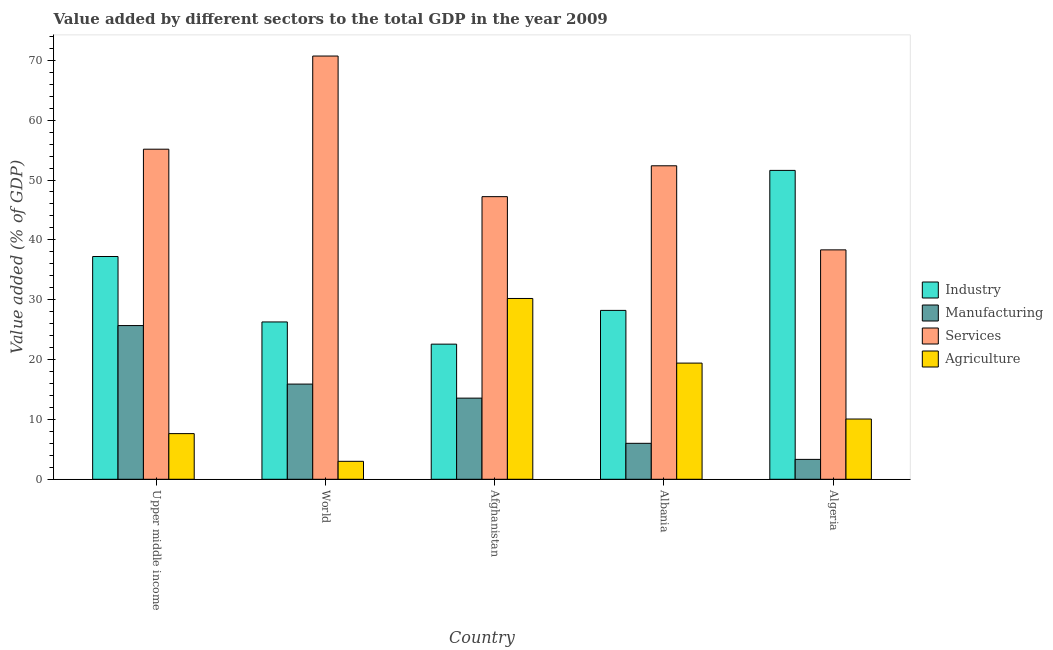What is the label of the 1st group of bars from the left?
Offer a very short reply. Upper middle income. In how many cases, is the number of bars for a given country not equal to the number of legend labels?
Your answer should be compact. 0. What is the value added by agricultural sector in World?
Offer a very short reply. 3. Across all countries, what is the maximum value added by manufacturing sector?
Ensure brevity in your answer.  25.68. Across all countries, what is the minimum value added by agricultural sector?
Provide a short and direct response. 3. In which country was the value added by agricultural sector maximum?
Provide a succinct answer. Afghanistan. What is the total value added by manufacturing sector in the graph?
Provide a succinct answer. 64.47. What is the difference between the value added by services sector in Algeria and that in Upper middle income?
Give a very brief answer. -16.82. What is the difference between the value added by manufacturing sector in Afghanistan and the value added by agricultural sector in Algeria?
Give a very brief answer. 3.49. What is the average value added by services sector per country?
Offer a terse response. 52.76. What is the difference between the value added by manufacturing sector and value added by industrial sector in Upper middle income?
Ensure brevity in your answer.  -11.54. What is the ratio of the value added by agricultural sector in Albania to that in Upper middle income?
Make the answer very short. 2.54. Is the value added by agricultural sector in Afghanistan less than that in Albania?
Make the answer very short. No. Is the difference between the value added by industrial sector in Albania and World greater than the difference between the value added by services sector in Albania and World?
Keep it short and to the point. Yes. What is the difference between the highest and the second highest value added by manufacturing sector?
Provide a succinct answer. 9.78. What is the difference between the highest and the lowest value added by industrial sector?
Ensure brevity in your answer.  29.03. In how many countries, is the value added by industrial sector greater than the average value added by industrial sector taken over all countries?
Provide a short and direct response. 2. Is the sum of the value added by manufacturing sector in Algeria and Upper middle income greater than the maximum value added by agricultural sector across all countries?
Make the answer very short. No. What does the 3rd bar from the left in Afghanistan represents?
Keep it short and to the point. Services. What does the 2nd bar from the right in Upper middle income represents?
Keep it short and to the point. Services. Is it the case that in every country, the sum of the value added by industrial sector and value added by manufacturing sector is greater than the value added by services sector?
Your response must be concise. No. How many bars are there?
Offer a terse response. 20. How many countries are there in the graph?
Give a very brief answer. 5. Does the graph contain grids?
Your answer should be very brief. No. Where does the legend appear in the graph?
Your answer should be very brief. Center right. How many legend labels are there?
Ensure brevity in your answer.  4. What is the title of the graph?
Provide a succinct answer. Value added by different sectors to the total GDP in the year 2009. What is the label or title of the Y-axis?
Make the answer very short. Value added (% of GDP). What is the Value added (% of GDP) of Industry in Upper middle income?
Offer a terse response. 37.22. What is the Value added (% of GDP) of Manufacturing in Upper middle income?
Your answer should be compact. 25.68. What is the Value added (% of GDP) of Services in Upper middle income?
Provide a short and direct response. 55.15. What is the Value added (% of GDP) of Agriculture in Upper middle income?
Provide a succinct answer. 7.63. What is the Value added (% of GDP) of Industry in World?
Your response must be concise. 26.29. What is the Value added (% of GDP) in Manufacturing in World?
Give a very brief answer. 15.9. What is the Value added (% of GDP) in Services in World?
Ensure brevity in your answer.  70.71. What is the Value added (% of GDP) of Agriculture in World?
Your answer should be compact. 3. What is the Value added (% of GDP) of Industry in Afghanistan?
Provide a succinct answer. 22.58. What is the Value added (% of GDP) in Manufacturing in Afghanistan?
Keep it short and to the point. 13.56. What is the Value added (% of GDP) of Services in Afghanistan?
Make the answer very short. 47.22. What is the Value added (% of GDP) of Agriculture in Afghanistan?
Make the answer very short. 30.21. What is the Value added (% of GDP) of Industry in Albania?
Offer a very short reply. 28.22. What is the Value added (% of GDP) in Manufacturing in Albania?
Provide a short and direct response. 6.01. What is the Value added (% of GDP) in Services in Albania?
Provide a short and direct response. 52.37. What is the Value added (% of GDP) of Agriculture in Albania?
Offer a very short reply. 19.41. What is the Value added (% of GDP) in Industry in Algeria?
Give a very brief answer. 51.6. What is the Value added (% of GDP) of Manufacturing in Algeria?
Give a very brief answer. 3.32. What is the Value added (% of GDP) in Services in Algeria?
Your answer should be compact. 38.33. What is the Value added (% of GDP) of Agriculture in Algeria?
Offer a terse response. 10.07. Across all countries, what is the maximum Value added (% of GDP) in Industry?
Your answer should be compact. 51.6. Across all countries, what is the maximum Value added (% of GDP) in Manufacturing?
Offer a very short reply. 25.68. Across all countries, what is the maximum Value added (% of GDP) in Services?
Your answer should be very brief. 70.71. Across all countries, what is the maximum Value added (% of GDP) of Agriculture?
Your answer should be very brief. 30.21. Across all countries, what is the minimum Value added (% of GDP) in Industry?
Your answer should be very brief. 22.58. Across all countries, what is the minimum Value added (% of GDP) in Manufacturing?
Your answer should be compact. 3.32. Across all countries, what is the minimum Value added (% of GDP) of Services?
Offer a terse response. 38.33. Across all countries, what is the minimum Value added (% of GDP) of Agriculture?
Provide a short and direct response. 3. What is the total Value added (% of GDP) of Industry in the graph?
Provide a succinct answer. 165.9. What is the total Value added (% of GDP) of Manufacturing in the graph?
Your answer should be compact. 64.47. What is the total Value added (% of GDP) of Services in the graph?
Give a very brief answer. 263.78. What is the total Value added (% of GDP) in Agriculture in the graph?
Your response must be concise. 70.31. What is the difference between the Value added (% of GDP) of Industry in Upper middle income and that in World?
Provide a succinct answer. 10.93. What is the difference between the Value added (% of GDP) of Manufacturing in Upper middle income and that in World?
Keep it short and to the point. 9.78. What is the difference between the Value added (% of GDP) of Services in Upper middle income and that in World?
Your response must be concise. -15.56. What is the difference between the Value added (% of GDP) in Agriculture in Upper middle income and that in World?
Provide a succinct answer. 4.63. What is the difference between the Value added (% of GDP) of Industry in Upper middle income and that in Afghanistan?
Make the answer very short. 14.64. What is the difference between the Value added (% of GDP) of Manufacturing in Upper middle income and that in Afghanistan?
Keep it short and to the point. 12.12. What is the difference between the Value added (% of GDP) in Services in Upper middle income and that in Afghanistan?
Provide a short and direct response. 7.93. What is the difference between the Value added (% of GDP) of Agriculture in Upper middle income and that in Afghanistan?
Offer a very short reply. -22.58. What is the difference between the Value added (% of GDP) of Industry in Upper middle income and that in Albania?
Offer a very short reply. 9. What is the difference between the Value added (% of GDP) in Manufacturing in Upper middle income and that in Albania?
Provide a short and direct response. 19.67. What is the difference between the Value added (% of GDP) of Services in Upper middle income and that in Albania?
Provide a short and direct response. 2.77. What is the difference between the Value added (% of GDP) of Agriculture in Upper middle income and that in Albania?
Your answer should be compact. -11.78. What is the difference between the Value added (% of GDP) in Industry in Upper middle income and that in Algeria?
Make the answer very short. -14.39. What is the difference between the Value added (% of GDP) in Manufacturing in Upper middle income and that in Algeria?
Your response must be concise. 22.36. What is the difference between the Value added (% of GDP) in Services in Upper middle income and that in Algeria?
Keep it short and to the point. 16.82. What is the difference between the Value added (% of GDP) of Agriculture in Upper middle income and that in Algeria?
Offer a terse response. -2.44. What is the difference between the Value added (% of GDP) in Industry in World and that in Afghanistan?
Offer a terse response. 3.71. What is the difference between the Value added (% of GDP) of Manufacturing in World and that in Afghanistan?
Offer a terse response. 2.35. What is the difference between the Value added (% of GDP) in Services in World and that in Afghanistan?
Give a very brief answer. 23.49. What is the difference between the Value added (% of GDP) in Agriculture in World and that in Afghanistan?
Ensure brevity in your answer.  -27.21. What is the difference between the Value added (% of GDP) of Industry in World and that in Albania?
Your response must be concise. -1.93. What is the difference between the Value added (% of GDP) of Manufacturing in World and that in Albania?
Keep it short and to the point. 9.9. What is the difference between the Value added (% of GDP) in Services in World and that in Albania?
Offer a terse response. 18.34. What is the difference between the Value added (% of GDP) of Agriculture in World and that in Albania?
Your answer should be compact. -16.41. What is the difference between the Value added (% of GDP) in Industry in World and that in Algeria?
Offer a very short reply. -25.32. What is the difference between the Value added (% of GDP) in Manufacturing in World and that in Algeria?
Keep it short and to the point. 12.58. What is the difference between the Value added (% of GDP) of Services in World and that in Algeria?
Your response must be concise. 32.38. What is the difference between the Value added (% of GDP) of Agriculture in World and that in Algeria?
Your response must be concise. -7.07. What is the difference between the Value added (% of GDP) of Industry in Afghanistan and that in Albania?
Offer a terse response. -5.64. What is the difference between the Value added (% of GDP) in Manufacturing in Afghanistan and that in Albania?
Keep it short and to the point. 7.55. What is the difference between the Value added (% of GDP) in Services in Afghanistan and that in Albania?
Offer a very short reply. -5.16. What is the difference between the Value added (% of GDP) of Agriculture in Afghanistan and that in Albania?
Provide a short and direct response. 10.8. What is the difference between the Value added (% of GDP) of Industry in Afghanistan and that in Algeria?
Keep it short and to the point. -29.03. What is the difference between the Value added (% of GDP) in Manufacturing in Afghanistan and that in Algeria?
Make the answer very short. 10.23. What is the difference between the Value added (% of GDP) of Services in Afghanistan and that in Algeria?
Keep it short and to the point. 8.89. What is the difference between the Value added (% of GDP) in Agriculture in Afghanistan and that in Algeria?
Provide a succinct answer. 20.14. What is the difference between the Value added (% of GDP) of Industry in Albania and that in Algeria?
Offer a terse response. -23.39. What is the difference between the Value added (% of GDP) in Manufacturing in Albania and that in Algeria?
Offer a terse response. 2.68. What is the difference between the Value added (% of GDP) of Services in Albania and that in Algeria?
Offer a very short reply. 14.05. What is the difference between the Value added (% of GDP) of Agriculture in Albania and that in Algeria?
Offer a very short reply. 9.34. What is the difference between the Value added (% of GDP) of Industry in Upper middle income and the Value added (% of GDP) of Manufacturing in World?
Your answer should be compact. 21.32. What is the difference between the Value added (% of GDP) in Industry in Upper middle income and the Value added (% of GDP) in Services in World?
Provide a short and direct response. -33.49. What is the difference between the Value added (% of GDP) in Industry in Upper middle income and the Value added (% of GDP) in Agriculture in World?
Keep it short and to the point. 34.22. What is the difference between the Value added (% of GDP) in Manufacturing in Upper middle income and the Value added (% of GDP) in Services in World?
Give a very brief answer. -45.03. What is the difference between the Value added (% of GDP) of Manufacturing in Upper middle income and the Value added (% of GDP) of Agriculture in World?
Provide a succinct answer. 22.68. What is the difference between the Value added (% of GDP) of Services in Upper middle income and the Value added (% of GDP) of Agriculture in World?
Ensure brevity in your answer.  52.15. What is the difference between the Value added (% of GDP) of Industry in Upper middle income and the Value added (% of GDP) of Manufacturing in Afghanistan?
Ensure brevity in your answer.  23.66. What is the difference between the Value added (% of GDP) of Industry in Upper middle income and the Value added (% of GDP) of Services in Afghanistan?
Keep it short and to the point. -10. What is the difference between the Value added (% of GDP) of Industry in Upper middle income and the Value added (% of GDP) of Agriculture in Afghanistan?
Keep it short and to the point. 7.01. What is the difference between the Value added (% of GDP) in Manufacturing in Upper middle income and the Value added (% of GDP) in Services in Afghanistan?
Provide a short and direct response. -21.54. What is the difference between the Value added (% of GDP) in Manufacturing in Upper middle income and the Value added (% of GDP) in Agriculture in Afghanistan?
Provide a short and direct response. -4.52. What is the difference between the Value added (% of GDP) of Services in Upper middle income and the Value added (% of GDP) of Agriculture in Afghanistan?
Make the answer very short. 24.94. What is the difference between the Value added (% of GDP) in Industry in Upper middle income and the Value added (% of GDP) in Manufacturing in Albania?
Make the answer very short. 31.21. What is the difference between the Value added (% of GDP) in Industry in Upper middle income and the Value added (% of GDP) in Services in Albania?
Offer a terse response. -15.16. What is the difference between the Value added (% of GDP) of Industry in Upper middle income and the Value added (% of GDP) of Agriculture in Albania?
Make the answer very short. 17.81. What is the difference between the Value added (% of GDP) of Manufacturing in Upper middle income and the Value added (% of GDP) of Services in Albania?
Provide a short and direct response. -26.69. What is the difference between the Value added (% of GDP) of Manufacturing in Upper middle income and the Value added (% of GDP) of Agriculture in Albania?
Provide a short and direct response. 6.27. What is the difference between the Value added (% of GDP) of Services in Upper middle income and the Value added (% of GDP) of Agriculture in Albania?
Provide a short and direct response. 35.74. What is the difference between the Value added (% of GDP) in Industry in Upper middle income and the Value added (% of GDP) in Manufacturing in Algeria?
Ensure brevity in your answer.  33.89. What is the difference between the Value added (% of GDP) of Industry in Upper middle income and the Value added (% of GDP) of Services in Algeria?
Offer a very short reply. -1.11. What is the difference between the Value added (% of GDP) in Industry in Upper middle income and the Value added (% of GDP) in Agriculture in Algeria?
Offer a very short reply. 27.15. What is the difference between the Value added (% of GDP) of Manufacturing in Upper middle income and the Value added (% of GDP) of Services in Algeria?
Your answer should be compact. -12.65. What is the difference between the Value added (% of GDP) of Manufacturing in Upper middle income and the Value added (% of GDP) of Agriculture in Algeria?
Offer a terse response. 15.61. What is the difference between the Value added (% of GDP) in Services in Upper middle income and the Value added (% of GDP) in Agriculture in Algeria?
Your response must be concise. 45.08. What is the difference between the Value added (% of GDP) in Industry in World and the Value added (% of GDP) in Manufacturing in Afghanistan?
Your answer should be very brief. 12.73. What is the difference between the Value added (% of GDP) in Industry in World and the Value added (% of GDP) in Services in Afghanistan?
Your answer should be very brief. -20.93. What is the difference between the Value added (% of GDP) of Industry in World and the Value added (% of GDP) of Agriculture in Afghanistan?
Provide a short and direct response. -3.92. What is the difference between the Value added (% of GDP) in Manufacturing in World and the Value added (% of GDP) in Services in Afghanistan?
Your response must be concise. -31.32. What is the difference between the Value added (% of GDP) of Manufacturing in World and the Value added (% of GDP) of Agriculture in Afghanistan?
Your answer should be compact. -14.3. What is the difference between the Value added (% of GDP) in Services in World and the Value added (% of GDP) in Agriculture in Afghanistan?
Ensure brevity in your answer.  40.51. What is the difference between the Value added (% of GDP) of Industry in World and the Value added (% of GDP) of Manufacturing in Albania?
Provide a short and direct response. 20.28. What is the difference between the Value added (% of GDP) in Industry in World and the Value added (% of GDP) in Services in Albania?
Give a very brief answer. -26.09. What is the difference between the Value added (% of GDP) of Industry in World and the Value added (% of GDP) of Agriculture in Albania?
Offer a very short reply. 6.88. What is the difference between the Value added (% of GDP) in Manufacturing in World and the Value added (% of GDP) in Services in Albania?
Your answer should be very brief. -36.47. What is the difference between the Value added (% of GDP) in Manufacturing in World and the Value added (% of GDP) in Agriculture in Albania?
Keep it short and to the point. -3.51. What is the difference between the Value added (% of GDP) in Services in World and the Value added (% of GDP) in Agriculture in Albania?
Provide a short and direct response. 51.3. What is the difference between the Value added (% of GDP) of Industry in World and the Value added (% of GDP) of Manufacturing in Algeria?
Provide a succinct answer. 22.96. What is the difference between the Value added (% of GDP) in Industry in World and the Value added (% of GDP) in Services in Algeria?
Your answer should be compact. -12.04. What is the difference between the Value added (% of GDP) in Industry in World and the Value added (% of GDP) in Agriculture in Algeria?
Your answer should be very brief. 16.22. What is the difference between the Value added (% of GDP) of Manufacturing in World and the Value added (% of GDP) of Services in Algeria?
Provide a short and direct response. -22.43. What is the difference between the Value added (% of GDP) of Manufacturing in World and the Value added (% of GDP) of Agriculture in Algeria?
Give a very brief answer. 5.84. What is the difference between the Value added (% of GDP) in Services in World and the Value added (% of GDP) in Agriculture in Algeria?
Give a very brief answer. 60.65. What is the difference between the Value added (% of GDP) in Industry in Afghanistan and the Value added (% of GDP) in Manufacturing in Albania?
Ensure brevity in your answer.  16.57. What is the difference between the Value added (% of GDP) in Industry in Afghanistan and the Value added (% of GDP) in Services in Albania?
Your response must be concise. -29.8. What is the difference between the Value added (% of GDP) of Industry in Afghanistan and the Value added (% of GDP) of Agriculture in Albania?
Your response must be concise. 3.17. What is the difference between the Value added (% of GDP) in Manufacturing in Afghanistan and the Value added (% of GDP) in Services in Albania?
Provide a succinct answer. -38.82. What is the difference between the Value added (% of GDP) of Manufacturing in Afghanistan and the Value added (% of GDP) of Agriculture in Albania?
Provide a short and direct response. -5.85. What is the difference between the Value added (% of GDP) in Services in Afghanistan and the Value added (% of GDP) in Agriculture in Albania?
Your answer should be very brief. 27.81. What is the difference between the Value added (% of GDP) of Industry in Afghanistan and the Value added (% of GDP) of Manufacturing in Algeria?
Offer a terse response. 19.25. What is the difference between the Value added (% of GDP) in Industry in Afghanistan and the Value added (% of GDP) in Services in Algeria?
Keep it short and to the point. -15.75. What is the difference between the Value added (% of GDP) in Industry in Afghanistan and the Value added (% of GDP) in Agriculture in Algeria?
Keep it short and to the point. 12.51. What is the difference between the Value added (% of GDP) of Manufacturing in Afghanistan and the Value added (% of GDP) of Services in Algeria?
Offer a very short reply. -24.77. What is the difference between the Value added (% of GDP) of Manufacturing in Afghanistan and the Value added (% of GDP) of Agriculture in Algeria?
Give a very brief answer. 3.49. What is the difference between the Value added (% of GDP) in Services in Afghanistan and the Value added (% of GDP) in Agriculture in Algeria?
Offer a terse response. 37.15. What is the difference between the Value added (% of GDP) of Industry in Albania and the Value added (% of GDP) of Manufacturing in Algeria?
Your answer should be very brief. 24.89. What is the difference between the Value added (% of GDP) of Industry in Albania and the Value added (% of GDP) of Services in Algeria?
Your response must be concise. -10.11. What is the difference between the Value added (% of GDP) of Industry in Albania and the Value added (% of GDP) of Agriculture in Algeria?
Offer a terse response. 18.15. What is the difference between the Value added (% of GDP) in Manufacturing in Albania and the Value added (% of GDP) in Services in Algeria?
Ensure brevity in your answer.  -32.32. What is the difference between the Value added (% of GDP) of Manufacturing in Albania and the Value added (% of GDP) of Agriculture in Algeria?
Your response must be concise. -4.06. What is the difference between the Value added (% of GDP) of Services in Albania and the Value added (% of GDP) of Agriculture in Algeria?
Make the answer very short. 42.31. What is the average Value added (% of GDP) in Industry per country?
Give a very brief answer. 33.18. What is the average Value added (% of GDP) of Manufacturing per country?
Offer a terse response. 12.89. What is the average Value added (% of GDP) of Services per country?
Offer a terse response. 52.76. What is the average Value added (% of GDP) of Agriculture per country?
Your answer should be very brief. 14.06. What is the difference between the Value added (% of GDP) of Industry and Value added (% of GDP) of Manufacturing in Upper middle income?
Make the answer very short. 11.54. What is the difference between the Value added (% of GDP) of Industry and Value added (% of GDP) of Services in Upper middle income?
Offer a terse response. -17.93. What is the difference between the Value added (% of GDP) of Industry and Value added (% of GDP) of Agriculture in Upper middle income?
Your response must be concise. 29.59. What is the difference between the Value added (% of GDP) of Manufacturing and Value added (% of GDP) of Services in Upper middle income?
Make the answer very short. -29.47. What is the difference between the Value added (% of GDP) in Manufacturing and Value added (% of GDP) in Agriculture in Upper middle income?
Give a very brief answer. 18.05. What is the difference between the Value added (% of GDP) in Services and Value added (% of GDP) in Agriculture in Upper middle income?
Provide a succinct answer. 47.52. What is the difference between the Value added (% of GDP) of Industry and Value added (% of GDP) of Manufacturing in World?
Make the answer very short. 10.38. What is the difference between the Value added (% of GDP) in Industry and Value added (% of GDP) in Services in World?
Keep it short and to the point. -44.43. What is the difference between the Value added (% of GDP) in Industry and Value added (% of GDP) in Agriculture in World?
Your response must be concise. 23.29. What is the difference between the Value added (% of GDP) in Manufacturing and Value added (% of GDP) in Services in World?
Ensure brevity in your answer.  -54.81. What is the difference between the Value added (% of GDP) in Manufacturing and Value added (% of GDP) in Agriculture in World?
Provide a succinct answer. 12.9. What is the difference between the Value added (% of GDP) in Services and Value added (% of GDP) in Agriculture in World?
Give a very brief answer. 67.71. What is the difference between the Value added (% of GDP) of Industry and Value added (% of GDP) of Manufacturing in Afghanistan?
Provide a succinct answer. 9.02. What is the difference between the Value added (% of GDP) in Industry and Value added (% of GDP) in Services in Afghanistan?
Provide a short and direct response. -24.64. What is the difference between the Value added (% of GDP) of Industry and Value added (% of GDP) of Agriculture in Afghanistan?
Offer a very short reply. -7.63. What is the difference between the Value added (% of GDP) in Manufacturing and Value added (% of GDP) in Services in Afghanistan?
Keep it short and to the point. -33.66. What is the difference between the Value added (% of GDP) of Manufacturing and Value added (% of GDP) of Agriculture in Afghanistan?
Give a very brief answer. -16.65. What is the difference between the Value added (% of GDP) of Services and Value added (% of GDP) of Agriculture in Afghanistan?
Provide a short and direct response. 17.01. What is the difference between the Value added (% of GDP) in Industry and Value added (% of GDP) in Manufacturing in Albania?
Provide a short and direct response. 22.21. What is the difference between the Value added (% of GDP) of Industry and Value added (% of GDP) of Services in Albania?
Keep it short and to the point. -24.16. What is the difference between the Value added (% of GDP) in Industry and Value added (% of GDP) in Agriculture in Albania?
Make the answer very short. 8.81. What is the difference between the Value added (% of GDP) of Manufacturing and Value added (% of GDP) of Services in Albania?
Your answer should be very brief. -46.37. What is the difference between the Value added (% of GDP) of Manufacturing and Value added (% of GDP) of Agriculture in Albania?
Your answer should be compact. -13.4. What is the difference between the Value added (% of GDP) in Services and Value added (% of GDP) in Agriculture in Albania?
Offer a terse response. 32.96. What is the difference between the Value added (% of GDP) of Industry and Value added (% of GDP) of Manufacturing in Algeria?
Give a very brief answer. 48.28. What is the difference between the Value added (% of GDP) of Industry and Value added (% of GDP) of Services in Algeria?
Your answer should be compact. 13.28. What is the difference between the Value added (% of GDP) of Industry and Value added (% of GDP) of Agriculture in Algeria?
Make the answer very short. 41.54. What is the difference between the Value added (% of GDP) in Manufacturing and Value added (% of GDP) in Services in Algeria?
Your response must be concise. -35.01. What is the difference between the Value added (% of GDP) of Manufacturing and Value added (% of GDP) of Agriculture in Algeria?
Ensure brevity in your answer.  -6.74. What is the difference between the Value added (% of GDP) of Services and Value added (% of GDP) of Agriculture in Algeria?
Give a very brief answer. 28.26. What is the ratio of the Value added (% of GDP) of Industry in Upper middle income to that in World?
Keep it short and to the point. 1.42. What is the ratio of the Value added (% of GDP) in Manufacturing in Upper middle income to that in World?
Keep it short and to the point. 1.61. What is the ratio of the Value added (% of GDP) of Services in Upper middle income to that in World?
Provide a succinct answer. 0.78. What is the ratio of the Value added (% of GDP) in Agriculture in Upper middle income to that in World?
Provide a short and direct response. 2.54. What is the ratio of the Value added (% of GDP) of Industry in Upper middle income to that in Afghanistan?
Keep it short and to the point. 1.65. What is the ratio of the Value added (% of GDP) in Manufacturing in Upper middle income to that in Afghanistan?
Ensure brevity in your answer.  1.89. What is the ratio of the Value added (% of GDP) of Services in Upper middle income to that in Afghanistan?
Provide a short and direct response. 1.17. What is the ratio of the Value added (% of GDP) in Agriculture in Upper middle income to that in Afghanistan?
Provide a short and direct response. 0.25. What is the ratio of the Value added (% of GDP) of Industry in Upper middle income to that in Albania?
Offer a very short reply. 1.32. What is the ratio of the Value added (% of GDP) of Manufacturing in Upper middle income to that in Albania?
Offer a very short reply. 4.28. What is the ratio of the Value added (% of GDP) in Services in Upper middle income to that in Albania?
Your response must be concise. 1.05. What is the ratio of the Value added (% of GDP) in Agriculture in Upper middle income to that in Albania?
Provide a short and direct response. 0.39. What is the ratio of the Value added (% of GDP) of Industry in Upper middle income to that in Algeria?
Keep it short and to the point. 0.72. What is the ratio of the Value added (% of GDP) in Manufacturing in Upper middle income to that in Algeria?
Offer a terse response. 7.73. What is the ratio of the Value added (% of GDP) in Services in Upper middle income to that in Algeria?
Offer a terse response. 1.44. What is the ratio of the Value added (% of GDP) in Agriculture in Upper middle income to that in Algeria?
Offer a terse response. 0.76. What is the ratio of the Value added (% of GDP) in Industry in World to that in Afghanistan?
Ensure brevity in your answer.  1.16. What is the ratio of the Value added (% of GDP) in Manufacturing in World to that in Afghanistan?
Your answer should be compact. 1.17. What is the ratio of the Value added (% of GDP) of Services in World to that in Afghanistan?
Your answer should be compact. 1.5. What is the ratio of the Value added (% of GDP) of Agriculture in World to that in Afghanistan?
Your response must be concise. 0.1. What is the ratio of the Value added (% of GDP) of Industry in World to that in Albania?
Keep it short and to the point. 0.93. What is the ratio of the Value added (% of GDP) in Manufacturing in World to that in Albania?
Your answer should be compact. 2.65. What is the ratio of the Value added (% of GDP) in Services in World to that in Albania?
Your answer should be compact. 1.35. What is the ratio of the Value added (% of GDP) of Agriculture in World to that in Albania?
Your response must be concise. 0.15. What is the ratio of the Value added (% of GDP) in Industry in World to that in Algeria?
Keep it short and to the point. 0.51. What is the ratio of the Value added (% of GDP) in Manufacturing in World to that in Algeria?
Keep it short and to the point. 4.79. What is the ratio of the Value added (% of GDP) of Services in World to that in Algeria?
Provide a succinct answer. 1.84. What is the ratio of the Value added (% of GDP) of Agriculture in World to that in Algeria?
Make the answer very short. 0.3. What is the ratio of the Value added (% of GDP) of Industry in Afghanistan to that in Albania?
Ensure brevity in your answer.  0.8. What is the ratio of the Value added (% of GDP) of Manufacturing in Afghanistan to that in Albania?
Provide a short and direct response. 2.26. What is the ratio of the Value added (% of GDP) of Services in Afghanistan to that in Albania?
Offer a very short reply. 0.9. What is the ratio of the Value added (% of GDP) of Agriculture in Afghanistan to that in Albania?
Ensure brevity in your answer.  1.56. What is the ratio of the Value added (% of GDP) of Industry in Afghanistan to that in Algeria?
Your response must be concise. 0.44. What is the ratio of the Value added (% of GDP) of Manufacturing in Afghanistan to that in Algeria?
Give a very brief answer. 4.08. What is the ratio of the Value added (% of GDP) in Services in Afghanistan to that in Algeria?
Keep it short and to the point. 1.23. What is the ratio of the Value added (% of GDP) in Agriculture in Afghanistan to that in Algeria?
Offer a very short reply. 3. What is the ratio of the Value added (% of GDP) of Industry in Albania to that in Algeria?
Provide a succinct answer. 0.55. What is the ratio of the Value added (% of GDP) in Manufacturing in Albania to that in Algeria?
Your answer should be compact. 1.81. What is the ratio of the Value added (% of GDP) in Services in Albania to that in Algeria?
Your response must be concise. 1.37. What is the ratio of the Value added (% of GDP) in Agriculture in Albania to that in Algeria?
Provide a short and direct response. 1.93. What is the difference between the highest and the second highest Value added (% of GDP) of Industry?
Give a very brief answer. 14.39. What is the difference between the highest and the second highest Value added (% of GDP) of Manufacturing?
Your answer should be compact. 9.78. What is the difference between the highest and the second highest Value added (% of GDP) in Services?
Offer a very short reply. 15.56. What is the difference between the highest and the second highest Value added (% of GDP) of Agriculture?
Your answer should be very brief. 10.8. What is the difference between the highest and the lowest Value added (% of GDP) of Industry?
Give a very brief answer. 29.03. What is the difference between the highest and the lowest Value added (% of GDP) of Manufacturing?
Provide a short and direct response. 22.36. What is the difference between the highest and the lowest Value added (% of GDP) of Services?
Offer a very short reply. 32.38. What is the difference between the highest and the lowest Value added (% of GDP) of Agriculture?
Your answer should be very brief. 27.21. 